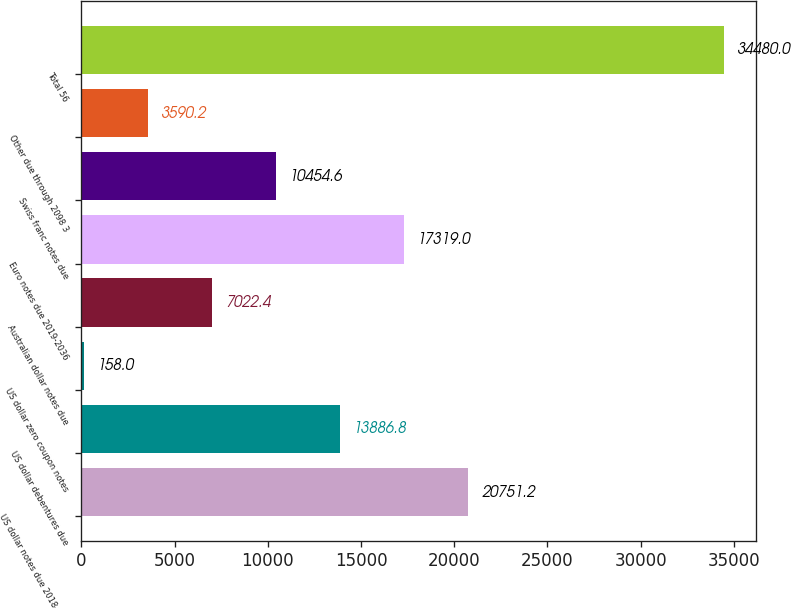Convert chart. <chart><loc_0><loc_0><loc_500><loc_500><bar_chart><fcel>US dollar notes due 2018-2093<fcel>US dollar debentures due<fcel>US dollar zero coupon notes<fcel>Australian dollar notes due<fcel>Euro notes due 2019-2036<fcel>Swiss franc notes due<fcel>Other due through 2098 3<fcel>Total 56<nl><fcel>20751.2<fcel>13886.8<fcel>158<fcel>7022.4<fcel>17319<fcel>10454.6<fcel>3590.2<fcel>34480<nl></chart> 